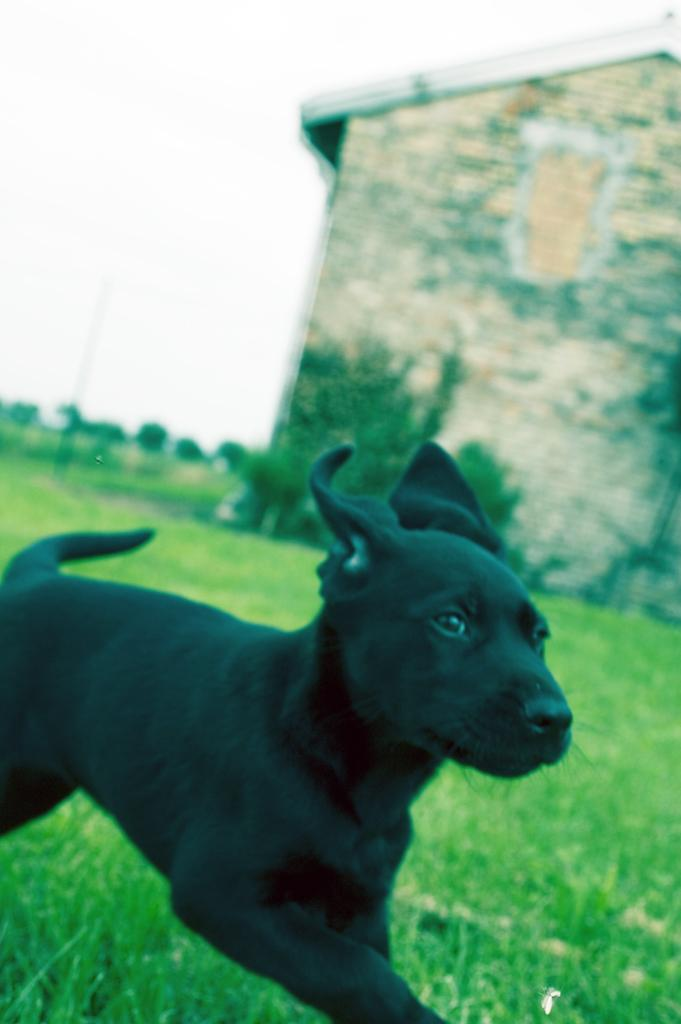What type of animal is in the image? There is a black dog in the image. What is the dog doing in the image? The dog is running on the grass. What can be seen on the right side of the image? There is a building on the right side of the image. What type of vegetation is visible in the background of the image? There are many plants and trees visible in the background of the image. What is visible in the sky in the image? The sky is visible in the image. What type of seed is the dog attempting to plant in the image? There is no seed present in the image, nor is the dog attempting to plant anything. 